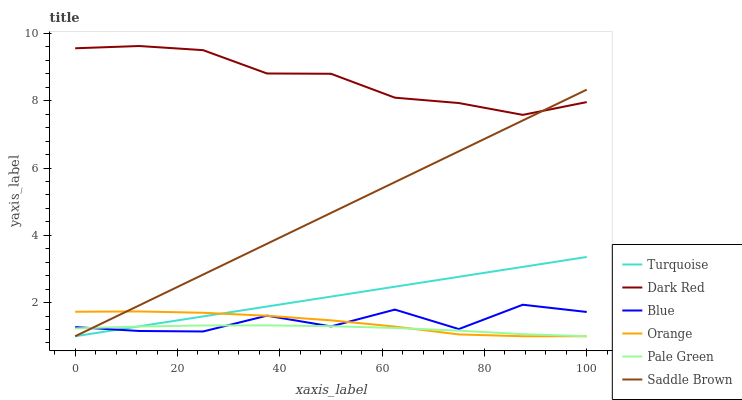Does Pale Green have the minimum area under the curve?
Answer yes or no. Yes. Does Dark Red have the maximum area under the curve?
Answer yes or no. Yes. Does Turquoise have the minimum area under the curve?
Answer yes or no. No. Does Turquoise have the maximum area under the curve?
Answer yes or no. No. Is Turquoise the smoothest?
Answer yes or no. Yes. Is Blue the roughest?
Answer yes or no. Yes. Is Dark Red the smoothest?
Answer yes or no. No. Is Dark Red the roughest?
Answer yes or no. No. Does Turquoise have the lowest value?
Answer yes or no. Yes. Does Dark Red have the lowest value?
Answer yes or no. No. Does Dark Red have the highest value?
Answer yes or no. Yes. Does Turquoise have the highest value?
Answer yes or no. No. Is Pale Green less than Dark Red?
Answer yes or no. Yes. Is Dark Red greater than Pale Green?
Answer yes or no. Yes. Does Dark Red intersect Saddle Brown?
Answer yes or no. Yes. Is Dark Red less than Saddle Brown?
Answer yes or no. No. Is Dark Red greater than Saddle Brown?
Answer yes or no. No. Does Pale Green intersect Dark Red?
Answer yes or no. No. 